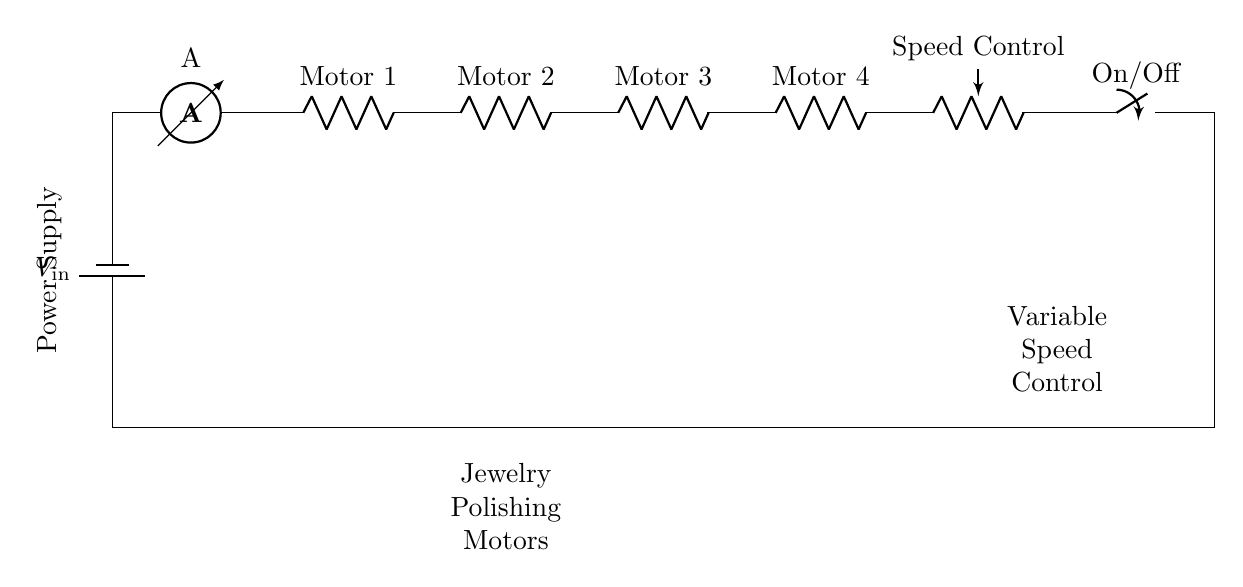What is the power supply type in this circuit? The power supply is represented as a battery, indicated by the symbol for a battery.
Answer: Battery How many motors are in this circuit? The diagram shows four motors connected in series, each designated as Motor 1, Motor 2, Motor 3, and Motor 4.
Answer: Four What component controls the speed of the motors? The component labeled as "Speed Control" is a potentiometer, which is used for variable resistance to control the motor speed.
Answer: Potentiometer What does the switch represent in this circuit? The switch labeled "On/Off" indicates that it can interrupt the circuit, controlling whether the current can flow through to the motors or not.
Answer: On/Off What is the connection type of the motors in this circuit? The motors are connected in series, meaning the same current flows through each motor one after another in a single path.
Answer: Series How would the total resistance of this circuit change if one motor fails? If one motor fails, the total resistance would increase significantly, leading to no current flow since it is a series circuit; all components need to function for current to flow.
Answer: No What would happen to the speed of all motors if the speed control is adjusted? Adjusting the speed control (potentiometer) would change the resistance and thus alter the voltage across the motors, affecting the speed of all motors simultaneously.
Answer: All motors change speed 